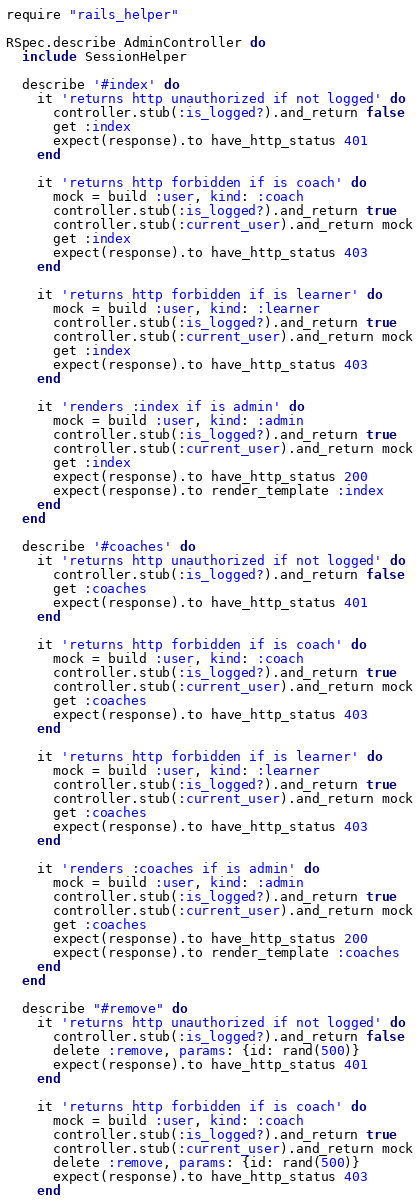Convert code to text. <code><loc_0><loc_0><loc_500><loc_500><_Ruby_>
require "rails_helper"

RSpec.describe AdminController do
  include SessionHelper

  describe '#index' do
    it 'returns http unauthorized if not logged' do
      controller.stub(:is_logged?).and_return false
      get :index
      expect(response).to have_http_status 401
    end

    it 'returns http forbidden if is coach' do
      mock = build :user, kind: :coach
      controller.stub(:is_logged?).and_return true
      controller.stub(:current_user).and_return mock
      get :index
      expect(response).to have_http_status 403
    end

    it 'returns http forbidden if is learner' do
      mock = build :user, kind: :learner
      controller.stub(:is_logged?).and_return true
      controller.stub(:current_user).and_return mock
      get :index
      expect(response).to have_http_status 403
    end

    it 'renders :index if is admin' do
      mock = build :user, kind: :admin
      controller.stub(:is_logged?).and_return true
      controller.stub(:current_user).and_return mock
      get :index
      expect(response).to have_http_status 200
      expect(response).to render_template :index
    end
  end

  describe '#coaches' do
    it 'returns http unauthorized if not logged' do
      controller.stub(:is_logged?).and_return false
      get :coaches
      expect(response).to have_http_status 401
    end

    it 'returns http forbidden if is coach' do
      mock = build :user, kind: :coach
      controller.stub(:is_logged?).and_return true
      controller.stub(:current_user).and_return mock
      get :coaches
      expect(response).to have_http_status 403
    end

    it 'returns http forbidden if is learner' do
      mock = build :user, kind: :learner
      controller.stub(:is_logged?).and_return true
      controller.stub(:current_user).and_return mock
      get :coaches
      expect(response).to have_http_status 403
    end

    it 'renders :coaches if is admin' do
      mock = build :user, kind: :admin
      controller.stub(:is_logged?).and_return true
      controller.stub(:current_user).and_return mock
      get :coaches
      expect(response).to have_http_status 200
      expect(response).to render_template :coaches
    end
  end

  describe "#remove" do
    it 'returns http unauthorized if not logged' do
      controller.stub(:is_logged?).and_return false
      delete :remove, params: {id: rand(500)}
      expect(response).to have_http_status 401
    end

    it 'returns http forbidden if is coach' do
      mock = build :user, kind: :coach
      controller.stub(:is_logged?).and_return true
      controller.stub(:current_user).and_return mock
      delete :remove, params: {id: rand(500)}
      expect(response).to have_http_status 403
    end
</code> 